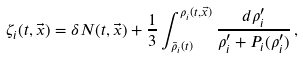<formula> <loc_0><loc_0><loc_500><loc_500>\zeta _ { i } ( t , \vec { x } ) = \delta N ( t , \vec { x } ) + \frac { 1 } { 3 } \int _ { \bar { \rho } _ { i } ( t ) } ^ { \rho _ { i } ( t , \vec { x } ) } \frac { d \rho _ { i } ^ { \prime } } { \rho _ { i } ^ { \prime } + P _ { i } ( \rho _ { i } ^ { \prime } ) } \, ,</formula> 